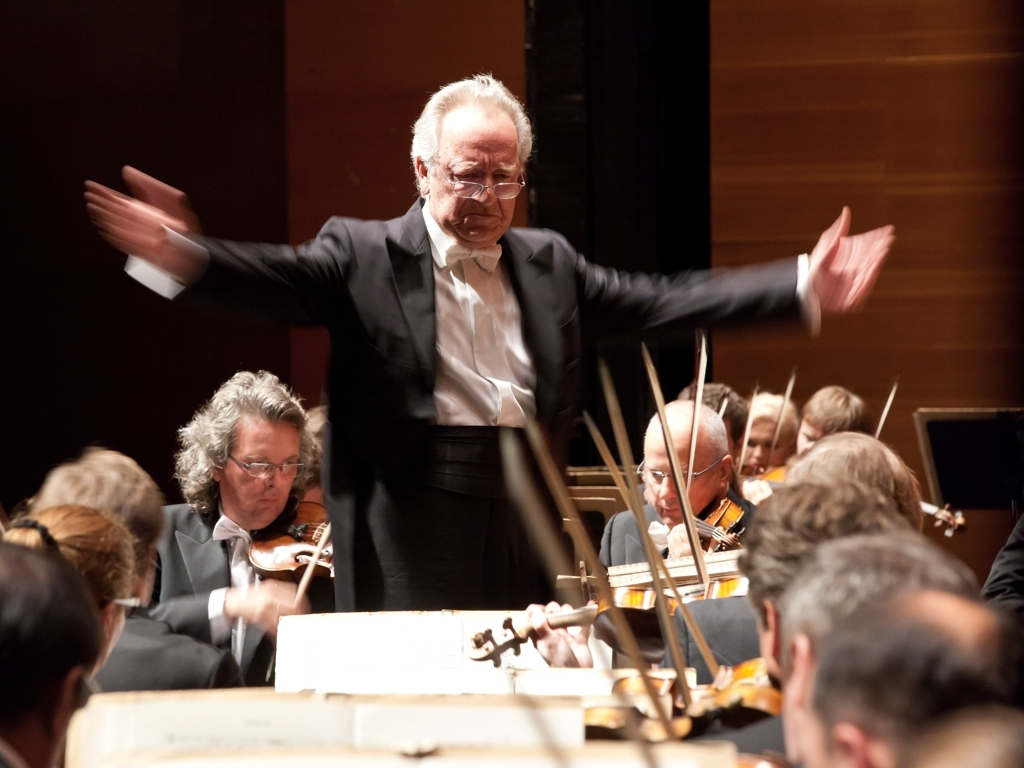What does the focusing issue result in?
A. Smoothing effect on the subject's hands
B. Significant motion blur in the subject's hands
C. Clear details in the subject's hands
D. Sharpness in the subject's hands
Answer with the option's letter from the given choices directly.
 B. 